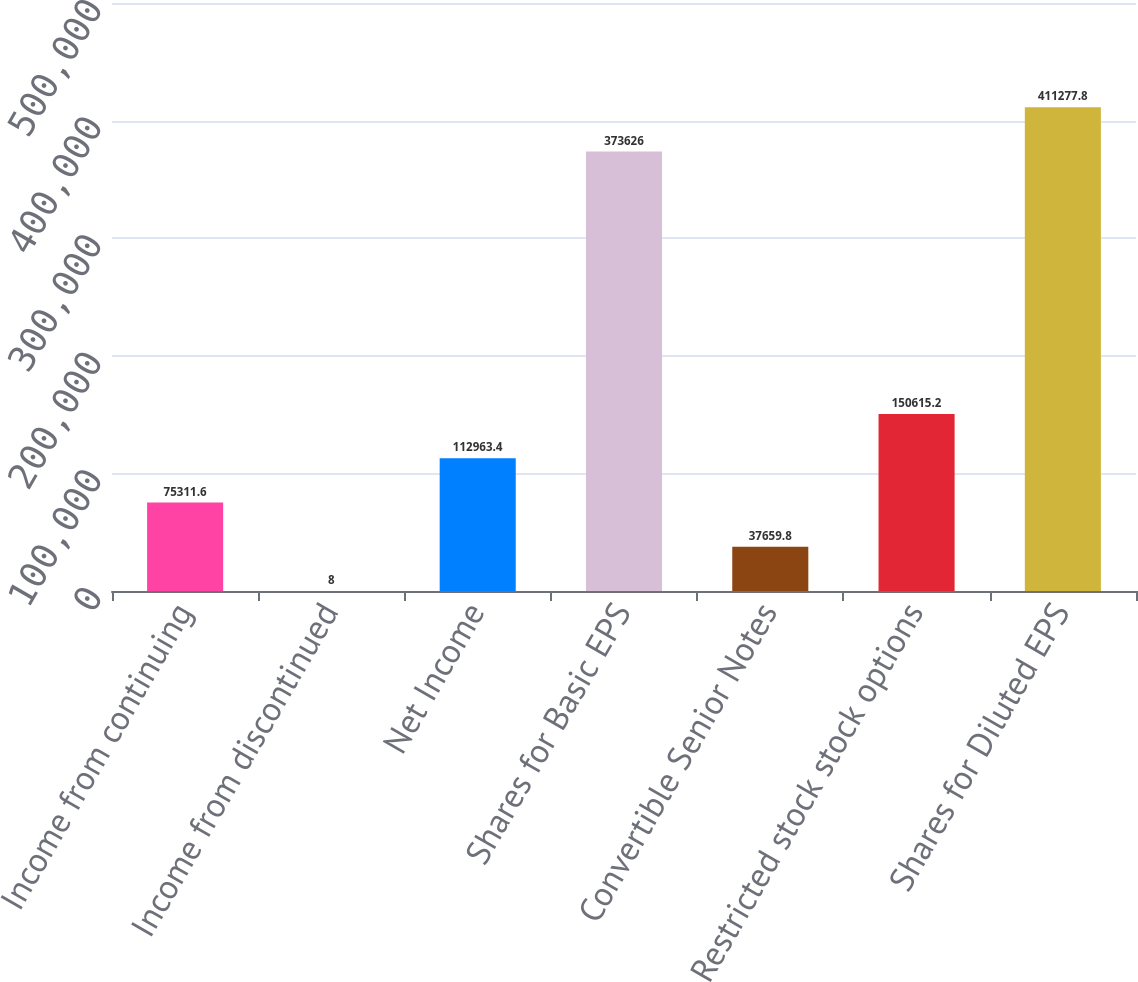Convert chart to OTSL. <chart><loc_0><loc_0><loc_500><loc_500><bar_chart><fcel>Income from continuing<fcel>Income from discontinued<fcel>Net Income<fcel>Shares for Basic EPS<fcel>Convertible Senior Notes<fcel>Restricted stock stock options<fcel>Shares for Diluted EPS<nl><fcel>75311.6<fcel>8<fcel>112963<fcel>373626<fcel>37659.8<fcel>150615<fcel>411278<nl></chart> 